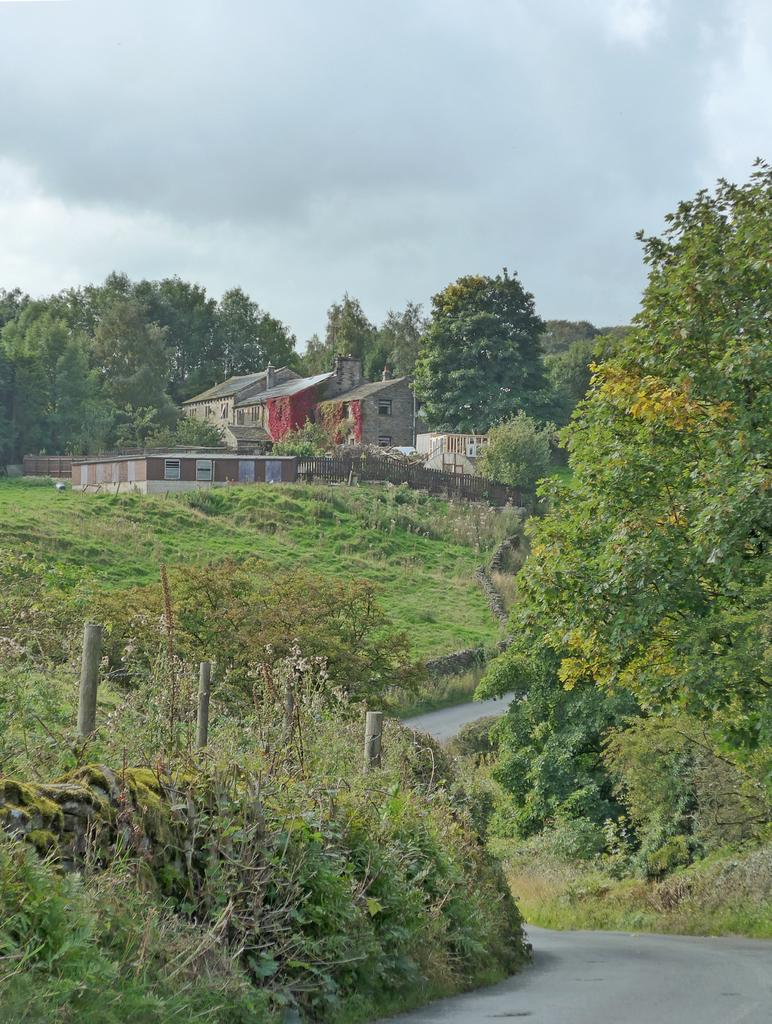What type of scenery is shown in the image? The image depicts a beautiful scenery. What can be seen on either side of the road in the image? There is a lot of grass on either side of the road. How many houses are visible on the left side of the road in the image? There are two houses on the left side of the road. What type of vegetation is present around the houses in the image? There are plenty of trees around the houses. What type of wrench is being used to reduce pollution in the image? There is no wrench or indication of pollution reduction in the image. 